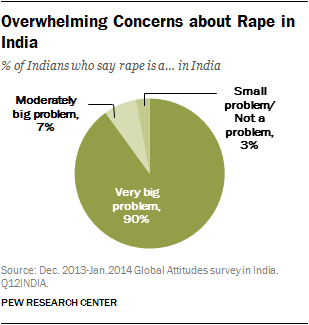How can this information be useful? This information can be incredibly useful for policymakers, NGOs, and social activists. Understanding the public perception as overwhelmingly considering rape a 'Very big problem' can drive the formulation of stricter laws, enhanced safety measures, and more effective public awareness campaigns aimed at combating this issue. Are there any details about the survey methodology? The source, PEW Research Center, conducted this survey as part of their 2013-2014 Global Attitudes survey in India. Detailed methodology typically includes sample size, demographic representation, and survey techniques but specifics would need to be checked directly from their release or website for this particular data. 